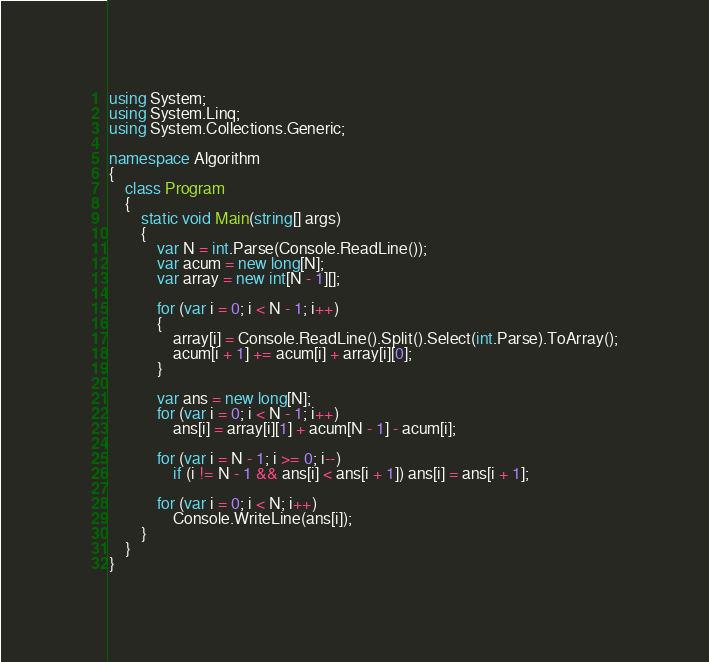<code> <loc_0><loc_0><loc_500><loc_500><_C#_>using System;
using System.Linq;
using System.Collections.Generic;

namespace Algorithm
{
    class Program
    {
        static void Main(string[] args)
        {
            var N = int.Parse(Console.ReadLine());
            var acum = new long[N];
            var array = new int[N - 1][];

            for (var i = 0; i < N - 1; i++)
            {
                array[i] = Console.ReadLine().Split().Select(int.Parse).ToArray();
                acum[i + 1] += acum[i] + array[i][0];
            }

            var ans = new long[N];
            for (var i = 0; i < N - 1; i++)
                ans[i] = array[i][1] + acum[N - 1] - acum[i];

            for (var i = N - 1; i >= 0; i--)
                if (i != N - 1 && ans[i] < ans[i + 1]) ans[i] = ans[i + 1];

            for (var i = 0; i < N; i++)
                Console.WriteLine(ans[i]);
        }
    }
}
</code> 